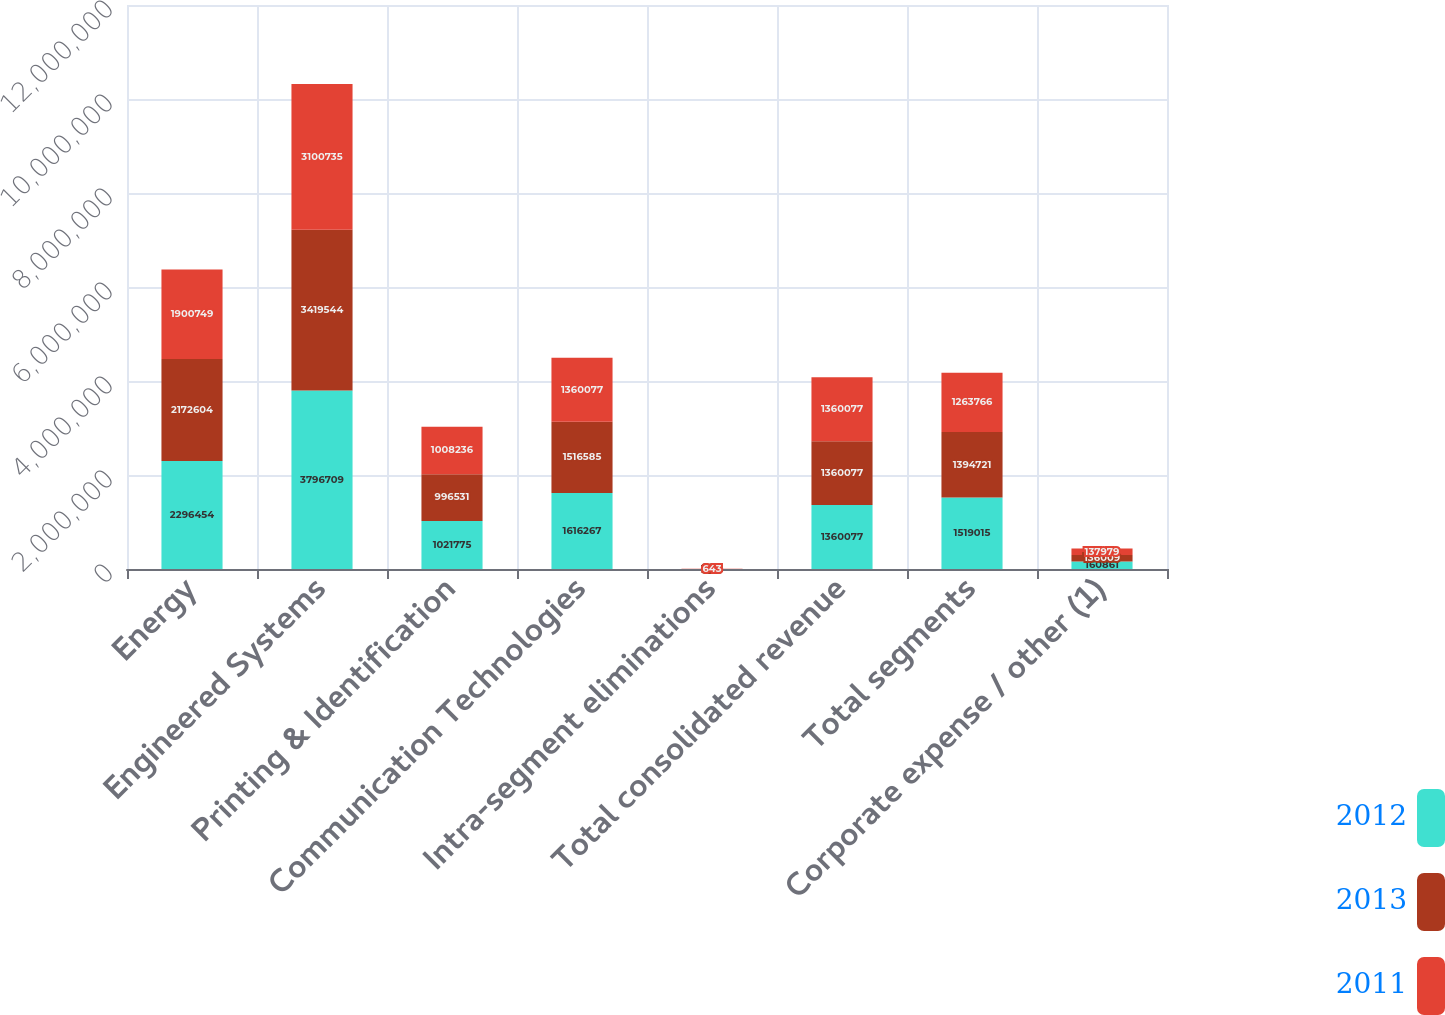<chart> <loc_0><loc_0><loc_500><loc_500><stacked_bar_chart><ecel><fcel>Energy<fcel>Engineered Systems<fcel>Printing & Identification<fcel>Communication Technologies<fcel>Intra-segment eliminations<fcel>Total consolidated revenue<fcel>Total segments<fcel>Corporate expense / other (1)<nl><fcel>2012<fcel>2.29645e+06<fcel>3.79671e+06<fcel>1.02178e+06<fcel>1.61627e+06<fcel>1392<fcel>1.36008e+06<fcel>1.51902e+06<fcel>160861<nl><fcel>2013<fcel>2.1726e+06<fcel>3.41954e+06<fcel>996531<fcel>1.51658e+06<fcel>925<fcel>1.36008e+06<fcel>1.39472e+06<fcel>136009<nl><fcel>2011<fcel>1.90075e+06<fcel>3.10074e+06<fcel>1.00824e+06<fcel>1.36008e+06<fcel>643<fcel>1.36008e+06<fcel>1.26377e+06<fcel>137979<nl></chart> 